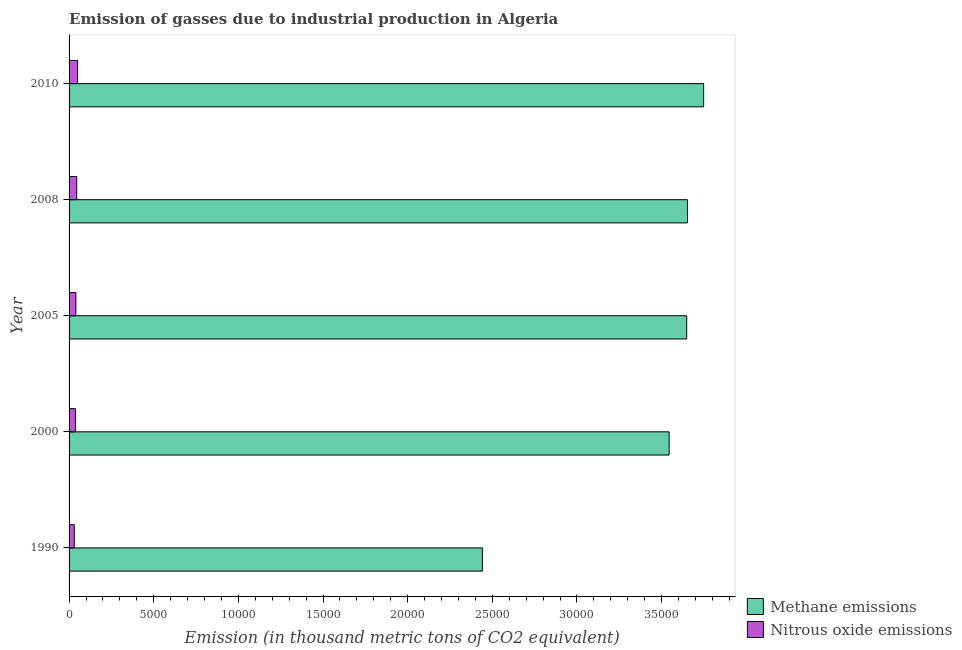How many groups of bars are there?
Keep it short and to the point. 5. Are the number of bars per tick equal to the number of legend labels?
Make the answer very short. Yes. How many bars are there on the 1st tick from the top?
Make the answer very short. 2. How many bars are there on the 4th tick from the bottom?
Make the answer very short. 2. In how many cases, is the number of bars for a given year not equal to the number of legend labels?
Offer a very short reply. 0. What is the amount of methane emissions in 1990?
Make the answer very short. 2.44e+04. Across all years, what is the maximum amount of methane emissions?
Ensure brevity in your answer.  3.75e+04. Across all years, what is the minimum amount of methane emissions?
Provide a short and direct response. 2.44e+04. In which year was the amount of nitrous oxide emissions maximum?
Your response must be concise. 2010. What is the total amount of methane emissions in the graph?
Keep it short and to the point. 1.70e+05. What is the difference between the amount of nitrous oxide emissions in 2005 and that in 2010?
Your answer should be compact. -98.6. What is the difference between the amount of nitrous oxide emissions in 2005 and the amount of methane emissions in 1990?
Offer a very short reply. -2.40e+04. What is the average amount of methane emissions per year?
Make the answer very short. 3.41e+04. In the year 1990, what is the difference between the amount of methane emissions and amount of nitrous oxide emissions?
Make the answer very short. 2.41e+04. In how many years, is the amount of nitrous oxide emissions greater than 26000 thousand metric tons?
Offer a very short reply. 0. What is the ratio of the amount of nitrous oxide emissions in 1990 to that in 2000?
Offer a very short reply. 0.82. Is the difference between the amount of nitrous oxide emissions in 1990 and 2000 greater than the difference between the amount of methane emissions in 1990 and 2000?
Give a very brief answer. Yes. What is the difference between the highest and the second highest amount of nitrous oxide emissions?
Offer a terse response. 48.2. What is the difference between the highest and the lowest amount of methane emissions?
Offer a terse response. 1.31e+04. What does the 2nd bar from the top in 2000 represents?
Your answer should be compact. Methane emissions. What does the 1st bar from the bottom in 2008 represents?
Your response must be concise. Methane emissions. How many bars are there?
Your answer should be very brief. 10. Are all the bars in the graph horizontal?
Give a very brief answer. Yes. How many years are there in the graph?
Make the answer very short. 5. Does the graph contain grids?
Ensure brevity in your answer.  No. Where does the legend appear in the graph?
Your answer should be compact. Bottom right. How many legend labels are there?
Keep it short and to the point. 2. How are the legend labels stacked?
Offer a very short reply. Vertical. What is the title of the graph?
Provide a succinct answer. Emission of gasses due to industrial production in Algeria. Does "Age 65(male)" appear as one of the legend labels in the graph?
Your answer should be very brief. No. What is the label or title of the X-axis?
Keep it short and to the point. Emission (in thousand metric tons of CO2 equivalent). What is the label or title of the Y-axis?
Give a very brief answer. Year. What is the Emission (in thousand metric tons of CO2 equivalent) of Methane emissions in 1990?
Give a very brief answer. 2.44e+04. What is the Emission (in thousand metric tons of CO2 equivalent) in Nitrous oxide emissions in 1990?
Offer a very short reply. 306.3. What is the Emission (in thousand metric tons of CO2 equivalent) of Methane emissions in 2000?
Your response must be concise. 3.54e+04. What is the Emission (in thousand metric tons of CO2 equivalent) in Nitrous oxide emissions in 2000?
Give a very brief answer. 374.2. What is the Emission (in thousand metric tons of CO2 equivalent) in Methane emissions in 2005?
Keep it short and to the point. 3.65e+04. What is the Emission (in thousand metric tons of CO2 equivalent) of Nitrous oxide emissions in 2005?
Give a very brief answer. 403.3. What is the Emission (in thousand metric tons of CO2 equivalent) in Methane emissions in 2008?
Your answer should be compact. 3.65e+04. What is the Emission (in thousand metric tons of CO2 equivalent) of Nitrous oxide emissions in 2008?
Give a very brief answer. 453.7. What is the Emission (in thousand metric tons of CO2 equivalent) of Methane emissions in 2010?
Keep it short and to the point. 3.75e+04. What is the Emission (in thousand metric tons of CO2 equivalent) in Nitrous oxide emissions in 2010?
Your answer should be very brief. 501.9. Across all years, what is the maximum Emission (in thousand metric tons of CO2 equivalent) of Methane emissions?
Provide a succinct answer. 3.75e+04. Across all years, what is the maximum Emission (in thousand metric tons of CO2 equivalent) in Nitrous oxide emissions?
Keep it short and to the point. 501.9. Across all years, what is the minimum Emission (in thousand metric tons of CO2 equivalent) of Methane emissions?
Your response must be concise. 2.44e+04. Across all years, what is the minimum Emission (in thousand metric tons of CO2 equivalent) in Nitrous oxide emissions?
Offer a terse response. 306.3. What is the total Emission (in thousand metric tons of CO2 equivalent) in Methane emissions in the graph?
Your answer should be very brief. 1.70e+05. What is the total Emission (in thousand metric tons of CO2 equivalent) in Nitrous oxide emissions in the graph?
Keep it short and to the point. 2039.4. What is the difference between the Emission (in thousand metric tons of CO2 equivalent) of Methane emissions in 1990 and that in 2000?
Provide a short and direct response. -1.10e+04. What is the difference between the Emission (in thousand metric tons of CO2 equivalent) in Nitrous oxide emissions in 1990 and that in 2000?
Your answer should be compact. -67.9. What is the difference between the Emission (in thousand metric tons of CO2 equivalent) in Methane emissions in 1990 and that in 2005?
Make the answer very short. -1.21e+04. What is the difference between the Emission (in thousand metric tons of CO2 equivalent) in Nitrous oxide emissions in 1990 and that in 2005?
Ensure brevity in your answer.  -97. What is the difference between the Emission (in thousand metric tons of CO2 equivalent) in Methane emissions in 1990 and that in 2008?
Keep it short and to the point. -1.21e+04. What is the difference between the Emission (in thousand metric tons of CO2 equivalent) of Nitrous oxide emissions in 1990 and that in 2008?
Offer a very short reply. -147.4. What is the difference between the Emission (in thousand metric tons of CO2 equivalent) of Methane emissions in 1990 and that in 2010?
Your answer should be very brief. -1.31e+04. What is the difference between the Emission (in thousand metric tons of CO2 equivalent) in Nitrous oxide emissions in 1990 and that in 2010?
Give a very brief answer. -195.6. What is the difference between the Emission (in thousand metric tons of CO2 equivalent) of Methane emissions in 2000 and that in 2005?
Offer a very short reply. -1037.5. What is the difference between the Emission (in thousand metric tons of CO2 equivalent) of Nitrous oxide emissions in 2000 and that in 2005?
Your answer should be very brief. -29.1. What is the difference between the Emission (in thousand metric tons of CO2 equivalent) in Methane emissions in 2000 and that in 2008?
Your answer should be very brief. -1082.4. What is the difference between the Emission (in thousand metric tons of CO2 equivalent) in Nitrous oxide emissions in 2000 and that in 2008?
Ensure brevity in your answer.  -79.5. What is the difference between the Emission (in thousand metric tons of CO2 equivalent) in Methane emissions in 2000 and that in 2010?
Offer a terse response. -2037.3. What is the difference between the Emission (in thousand metric tons of CO2 equivalent) of Nitrous oxide emissions in 2000 and that in 2010?
Your answer should be very brief. -127.7. What is the difference between the Emission (in thousand metric tons of CO2 equivalent) of Methane emissions in 2005 and that in 2008?
Ensure brevity in your answer.  -44.9. What is the difference between the Emission (in thousand metric tons of CO2 equivalent) of Nitrous oxide emissions in 2005 and that in 2008?
Provide a succinct answer. -50.4. What is the difference between the Emission (in thousand metric tons of CO2 equivalent) in Methane emissions in 2005 and that in 2010?
Your answer should be very brief. -999.8. What is the difference between the Emission (in thousand metric tons of CO2 equivalent) in Nitrous oxide emissions in 2005 and that in 2010?
Ensure brevity in your answer.  -98.6. What is the difference between the Emission (in thousand metric tons of CO2 equivalent) of Methane emissions in 2008 and that in 2010?
Offer a terse response. -954.9. What is the difference between the Emission (in thousand metric tons of CO2 equivalent) in Nitrous oxide emissions in 2008 and that in 2010?
Offer a terse response. -48.2. What is the difference between the Emission (in thousand metric tons of CO2 equivalent) of Methane emissions in 1990 and the Emission (in thousand metric tons of CO2 equivalent) of Nitrous oxide emissions in 2000?
Keep it short and to the point. 2.40e+04. What is the difference between the Emission (in thousand metric tons of CO2 equivalent) of Methane emissions in 1990 and the Emission (in thousand metric tons of CO2 equivalent) of Nitrous oxide emissions in 2005?
Ensure brevity in your answer.  2.40e+04. What is the difference between the Emission (in thousand metric tons of CO2 equivalent) in Methane emissions in 1990 and the Emission (in thousand metric tons of CO2 equivalent) in Nitrous oxide emissions in 2008?
Offer a terse response. 2.40e+04. What is the difference between the Emission (in thousand metric tons of CO2 equivalent) in Methane emissions in 1990 and the Emission (in thousand metric tons of CO2 equivalent) in Nitrous oxide emissions in 2010?
Offer a terse response. 2.39e+04. What is the difference between the Emission (in thousand metric tons of CO2 equivalent) of Methane emissions in 2000 and the Emission (in thousand metric tons of CO2 equivalent) of Nitrous oxide emissions in 2005?
Offer a terse response. 3.50e+04. What is the difference between the Emission (in thousand metric tons of CO2 equivalent) in Methane emissions in 2000 and the Emission (in thousand metric tons of CO2 equivalent) in Nitrous oxide emissions in 2008?
Provide a succinct answer. 3.50e+04. What is the difference between the Emission (in thousand metric tons of CO2 equivalent) in Methane emissions in 2000 and the Emission (in thousand metric tons of CO2 equivalent) in Nitrous oxide emissions in 2010?
Your answer should be compact. 3.49e+04. What is the difference between the Emission (in thousand metric tons of CO2 equivalent) of Methane emissions in 2005 and the Emission (in thousand metric tons of CO2 equivalent) of Nitrous oxide emissions in 2008?
Keep it short and to the point. 3.60e+04. What is the difference between the Emission (in thousand metric tons of CO2 equivalent) of Methane emissions in 2005 and the Emission (in thousand metric tons of CO2 equivalent) of Nitrous oxide emissions in 2010?
Provide a succinct answer. 3.60e+04. What is the difference between the Emission (in thousand metric tons of CO2 equivalent) of Methane emissions in 2008 and the Emission (in thousand metric tons of CO2 equivalent) of Nitrous oxide emissions in 2010?
Your answer should be compact. 3.60e+04. What is the average Emission (in thousand metric tons of CO2 equivalent) in Methane emissions per year?
Give a very brief answer. 3.41e+04. What is the average Emission (in thousand metric tons of CO2 equivalent) of Nitrous oxide emissions per year?
Your answer should be very brief. 407.88. In the year 1990, what is the difference between the Emission (in thousand metric tons of CO2 equivalent) in Methane emissions and Emission (in thousand metric tons of CO2 equivalent) in Nitrous oxide emissions?
Give a very brief answer. 2.41e+04. In the year 2000, what is the difference between the Emission (in thousand metric tons of CO2 equivalent) of Methane emissions and Emission (in thousand metric tons of CO2 equivalent) of Nitrous oxide emissions?
Ensure brevity in your answer.  3.51e+04. In the year 2005, what is the difference between the Emission (in thousand metric tons of CO2 equivalent) in Methane emissions and Emission (in thousand metric tons of CO2 equivalent) in Nitrous oxide emissions?
Keep it short and to the point. 3.61e+04. In the year 2008, what is the difference between the Emission (in thousand metric tons of CO2 equivalent) in Methane emissions and Emission (in thousand metric tons of CO2 equivalent) in Nitrous oxide emissions?
Provide a succinct answer. 3.61e+04. In the year 2010, what is the difference between the Emission (in thousand metric tons of CO2 equivalent) of Methane emissions and Emission (in thousand metric tons of CO2 equivalent) of Nitrous oxide emissions?
Provide a short and direct response. 3.70e+04. What is the ratio of the Emission (in thousand metric tons of CO2 equivalent) in Methane emissions in 1990 to that in 2000?
Make the answer very short. 0.69. What is the ratio of the Emission (in thousand metric tons of CO2 equivalent) in Nitrous oxide emissions in 1990 to that in 2000?
Offer a very short reply. 0.82. What is the ratio of the Emission (in thousand metric tons of CO2 equivalent) of Methane emissions in 1990 to that in 2005?
Ensure brevity in your answer.  0.67. What is the ratio of the Emission (in thousand metric tons of CO2 equivalent) in Nitrous oxide emissions in 1990 to that in 2005?
Ensure brevity in your answer.  0.76. What is the ratio of the Emission (in thousand metric tons of CO2 equivalent) of Methane emissions in 1990 to that in 2008?
Keep it short and to the point. 0.67. What is the ratio of the Emission (in thousand metric tons of CO2 equivalent) of Nitrous oxide emissions in 1990 to that in 2008?
Ensure brevity in your answer.  0.68. What is the ratio of the Emission (in thousand metric tons of CO2 equivalent) in Methane emissions in 1990 to that in 2010?
Your answer should be very brief. 0.65. What is the ratio of the Emission (in thousand metric tons of CO2 equivalent) of Nitrous oxide emissions in 1990 to that in 2010?
Your response must be concise. 0.61. What is the ratio of the Emission (in thousand metric tons of CO2 equivalent) in Methane emissions in 2000 to that in 2005?
Give a very brief answer. 0.97. What is the ratio of the Emission (in thousand metric tons of CO2 equivalent) of Nitrous oxide emissions in 2000 to that in 2005?
Your answer should be compact. 0.93. What is the ratio of the Emission (in thousand metric tons of CO2 equivalent) of Methane emissions in 2000 to that in 2008?
Provide a succinct answer. 0.97. What is the ratio of the Emission (in thousand metric tons of CO2 equivalent) of Nitrous oxide emissions in 2000 to that in 2008?
Your response must be concise. 0.82. What is the ratio of the Emission (in thousand metric tons of CO2 equivalent) of Methane emissions in 2000 to that in 2010?
Your answer should be compact. 0.95. What is the ratio of the Emission (in thousand metric tons of CO2 equivalent) of Nitrous oxide emissions in 2000 to that in 2010?
Give a very brief answer. 0.75. What is the ratio of the Emission (in thousand metric tons of CO2 equivalent) in Methane emissions in 2005 to that in 2010?
Make the answer very short. 0.97. What is the ratio of the Emission (in thousand metric tons of CO2 equivalent) in Nitrous oxide emissions in 2005 to that in 2010?
Your answer should be very brief. 0.8. What is the ratio of the Emission (in thousand metric tons of CO2 equivalent) of Methane emissions in 2008 to that in 2010?
Keep it short and to the point. 0.97. What is the ratio of the Emission (in thousand metric tons of CO2 equivalent) of Nitrous oxide emissions in 2008 to that in 2010?
Your response must be concise. 0.9. What is the difference between the highest and the second highest Emission (in thousand metric tons of CO2 equivalent) in Methane emissions?
Keep it short and to the point. 954.9. What is the difference between the highest and the second highest Emission (in thousand metric tons of CO2 equivalent) in Nitrous oxide emissions?
Keep it short and to the point. 48.2. What is the difference between the highest and the lowest Emission (in thousand metric tons of CO2 equivalent) of Methane emissions?
Offer a very short reply. 1.31e+04. What is the difference between the highest and the lowest Emission (in thousand metric tons of CO2 equivalent) in Nitrous oxide emissions?
Your answer should be very brief. 195.6. 